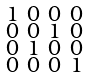Convert formula to latex. <formula><loc_0><loc_0><loc_500><loc_500>\begin{smallmatrix} 1 & 0 & 0 & 0 \\ 0 & 0 & 1 & 0 \\ 0 & 1 & 0 & 0 \\ 0 & 0 & 0 & 1 \\ \end{smallmatrix}</formula> 